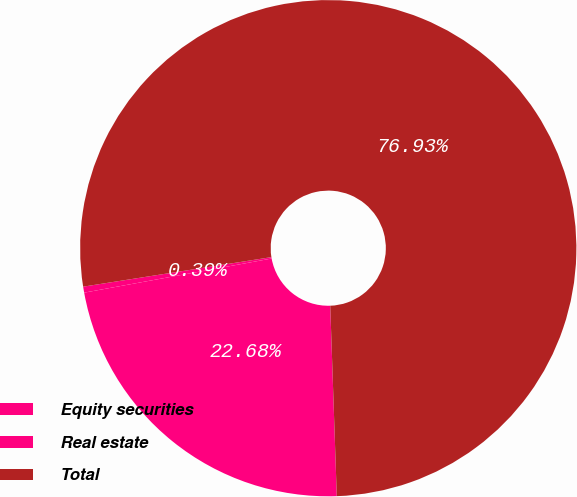Convert chart to OTSL. <chart><loc_0><loc_0><loc_500><loc_500><pie_chart><fcel>Equity securities<fcel>Real estate<fcel>Total<nl><fcel>22.68%<fcel>0.39%<fcel>76.93%<nl></chart> 